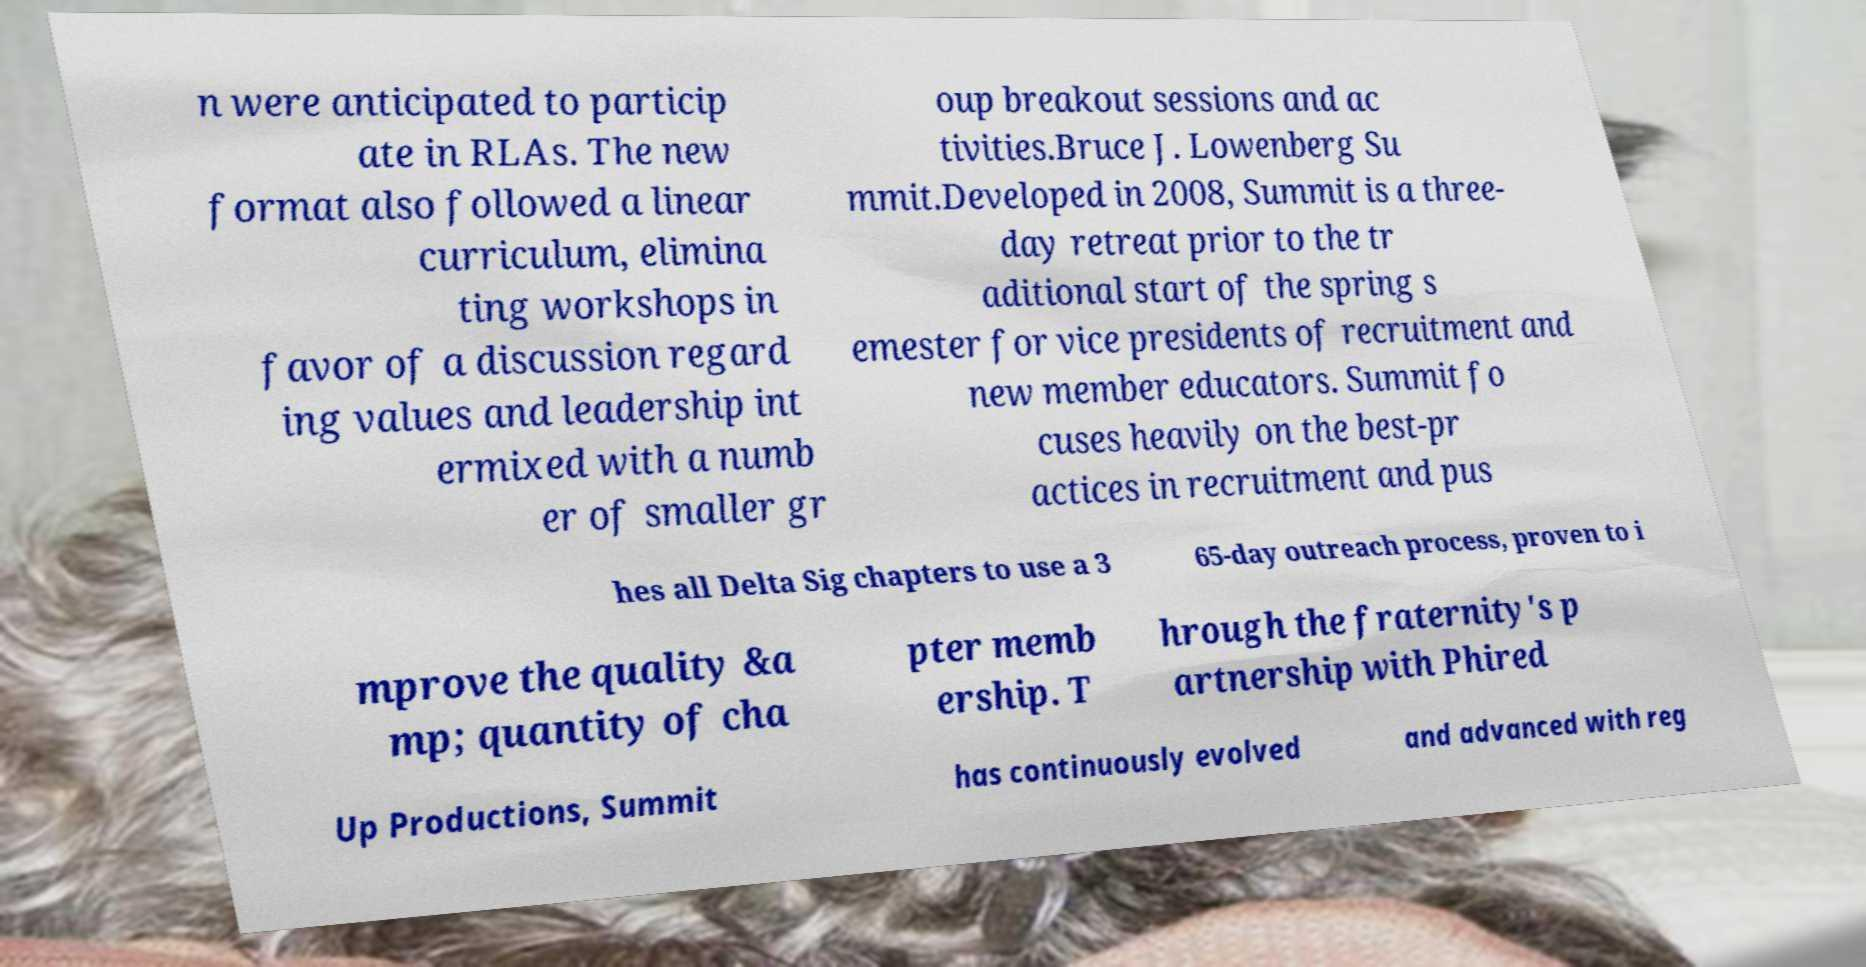Can you accurately transcribe the text from the provided image for me? n were anticipated to particip ate in RLAs. The new format also followed a linear curriculum, elimina ting workshops in favor of a discussion regard ing values and leadership int ermixed with a numb er of smaller gr oup breakout sessions and ac tivities.Bruce J. Lowenberg Su mmit.Developed in 2008, Summit is a three- day retreat prior to the tr aditional start of the spring s emester for vice presidents of recruitment and new member educators. Summit fo cuses heavily on the best-pr actices in recruitment and pus hes all Delta Sig chapters to use a 3 65-day outreach process, proven to i mprove the quality &a mp; quantity of cha pter memb ership. T hrough the fraternity's p artnership with Phired Up Productions, Summit has continuously evolved and advanced with reg 